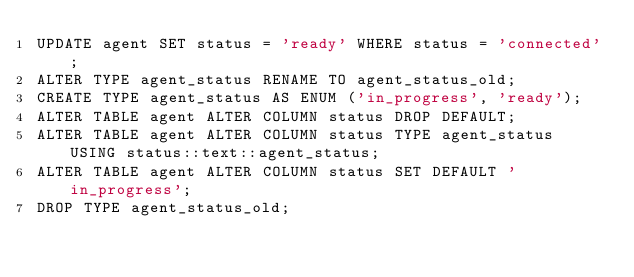<code> <loc_0><loc_0><loc_500><loc_500><_SQL_>UPDATE agent SET status = 'ready' WHERE status = 'connected';
ALTER TYPE agent_status RENAME TO agent_status_old;
CREATE TYPE agent_status AS ENUM ('in_progress', 'ready');
ALTER TABLE agent ALTER COLUMN status DROP DEFAULT;
ALTER TABLE agent ALTER COLUMN status TYPE agent_status USING status::text::agent_status;
ALTER TABLE agent ALTER COLUMN status SET DEFAULT 'in_progress';
DROP TYPE agent_status_old;
</code> 